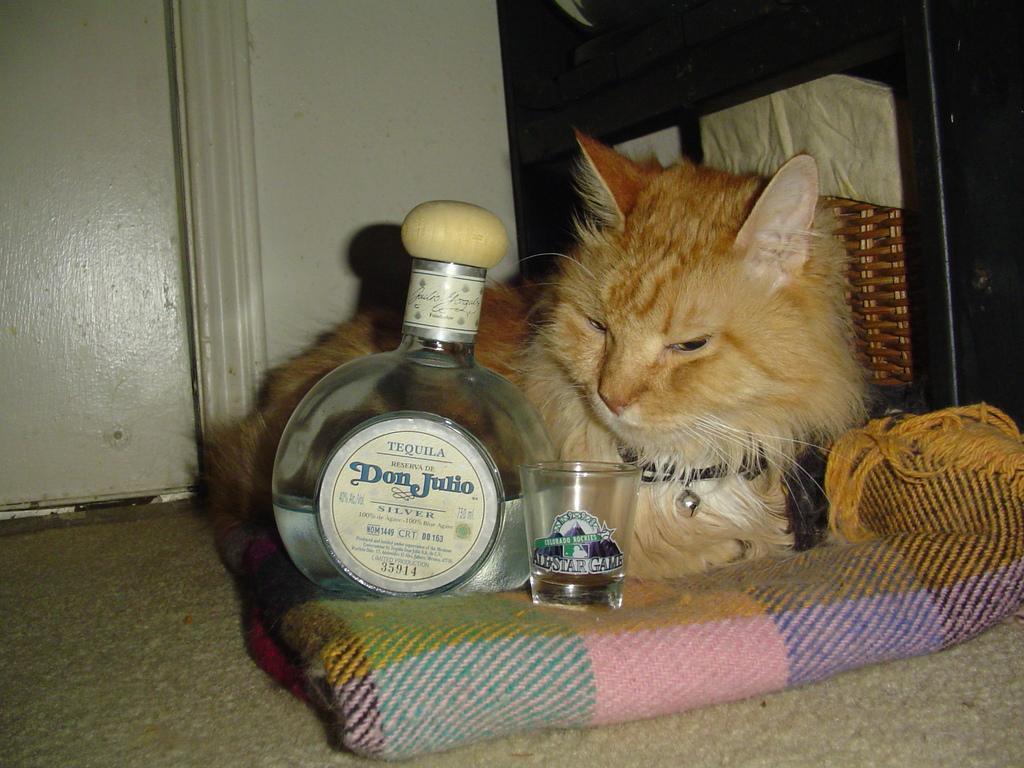Can you describe this image briefly? In this image I can see a cat sitting on the blanket. There is bottle and glass on the blanket. At the back side the wall is in white color. On the right side there a black rack. The cat has a bell on the neck. 